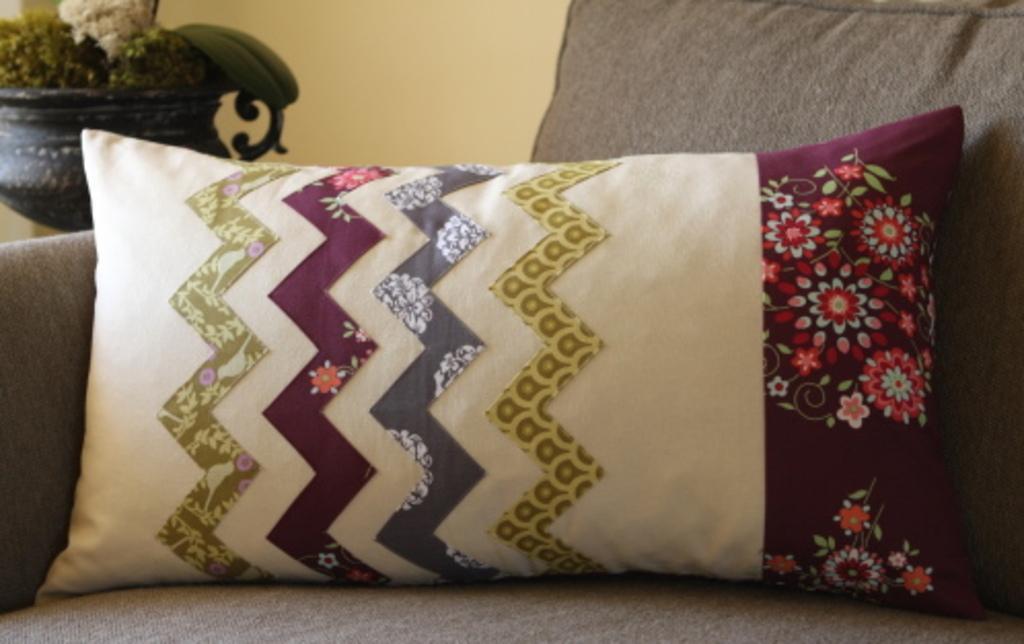In one or two sentences, can you explain what this image depicts? In the picture we can see a sofa on it, we can see two pillows one is gray in color and one is white and some part red in color with some designs on it and beside the sofa we can see a house plant near the wall. 